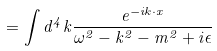<formula> <loc_0><loc_0><loc_500><loc_500>= \int d ^ { 4 } k \frac { e ^ { - i k \cdot x } } { \omega ^ { 2 } - k ^ { 2 } - m ^ { 2 } + i \epsilon }</formula> 